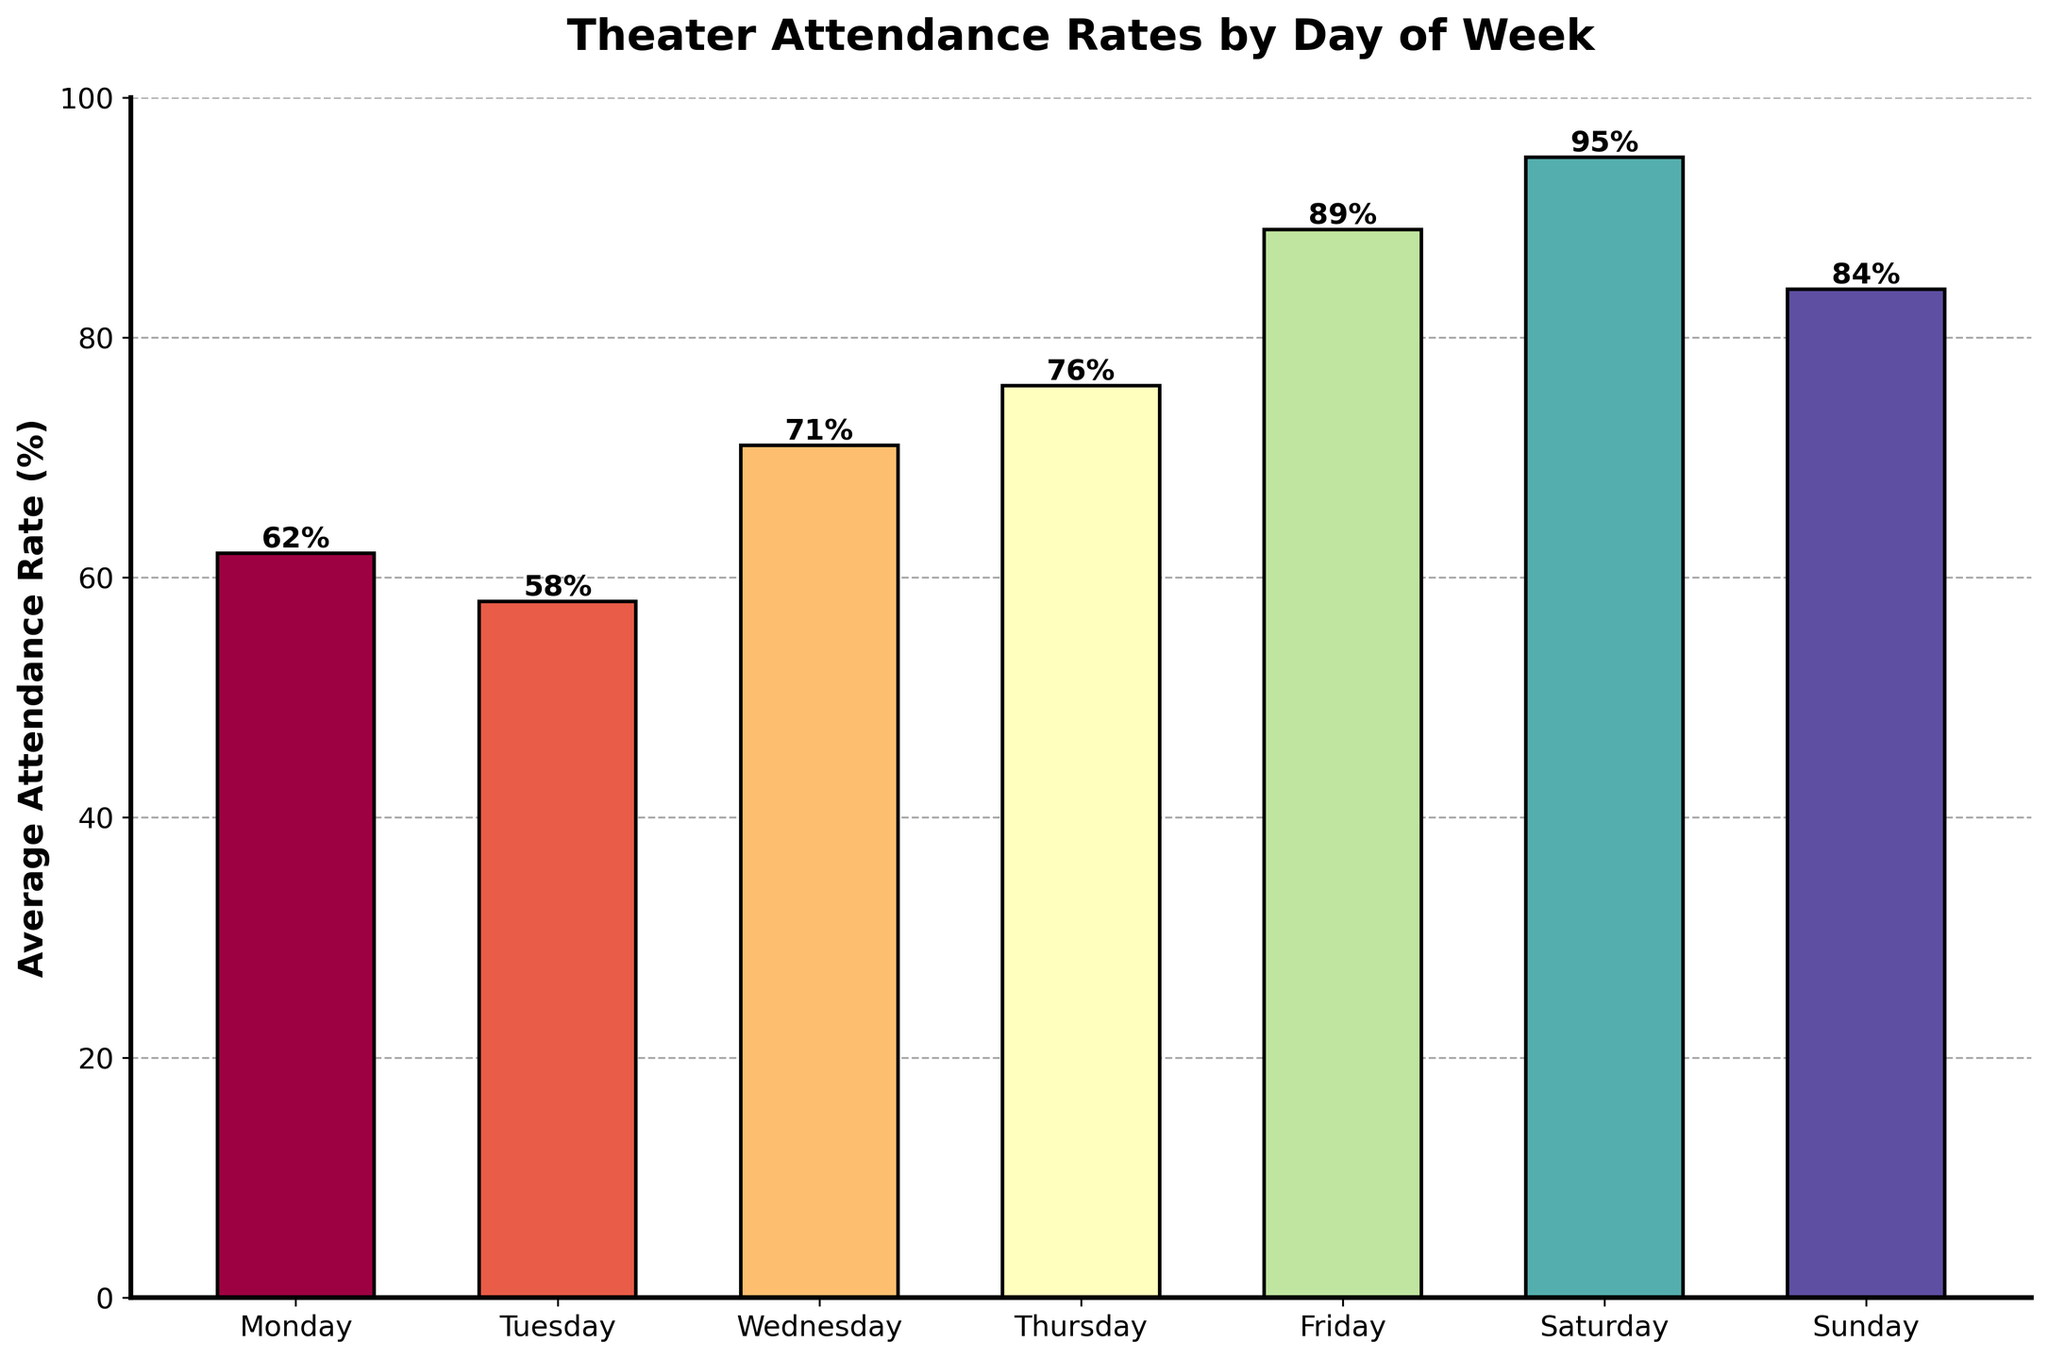what day has the highest attendance rate? The bar representing Saturday is the tallest among all bars, indicating the highest attendance rate.
Answer: Saturday what is the difference between attendance rates on Friday and Sunday? The attendance rate for Friday is 89% and for Sunday is 84%. The difference is 89% - 84% = 5%.
Answer: 5% which days have attendance rates above 80%? The bars for Friday, Saturday, and Sunday are all above the 80% mark.
Answer: Friday, Saturday, Sunday compare the attendance rates on Monday and Wednesday, which one is higher and by how much? Monday's attendance rate is 62% and Wednesday's is 71%. 71% - 62% = 9%. So, Wednesday is higher by 9%.
Answer: Wednesday, 9% what's the average attendance rate for weekdays (Monday to Friday)? The attendance rates for weekdays are 62%, 58%, 71%, 76%, and 89%. Adding these and dividing by 5 gives (62 + 58 + 71 + 76 + 89) / 5 = 71.2%.
Answer: 71.2% what is the total difference in attendance rates between Tuesday and Thursday? Tuesday's rate is 58% and Thursday's is 76%. The difference is 76% - 58% = 18%.
Answer: 18% how are the bars visually differentiated in the chart? The bars are distinguished by different colors with a gradient effect from a colormap, and the actual attendance rate percentages are placed above each bar.
Answer: Different colors, labeled percentages which day has the lowest attendance rate and by how much does it differ from the highest? Tuesday has the lowest attendance rate at 58%, and Saturday has the highest at 95%. The difference is 95% - 58% = 37%.
Answer: Tuesday, 37% what is the attendance rate trend from Monday through Sunday? The attendance rates initially fluctuate, start lower on Monday (62%), reach a peak on Saturday (95%), and then slightly decrease on Sunday (84%).
Answer: Increasing trend to Saturday, slight decrease on Sunday 